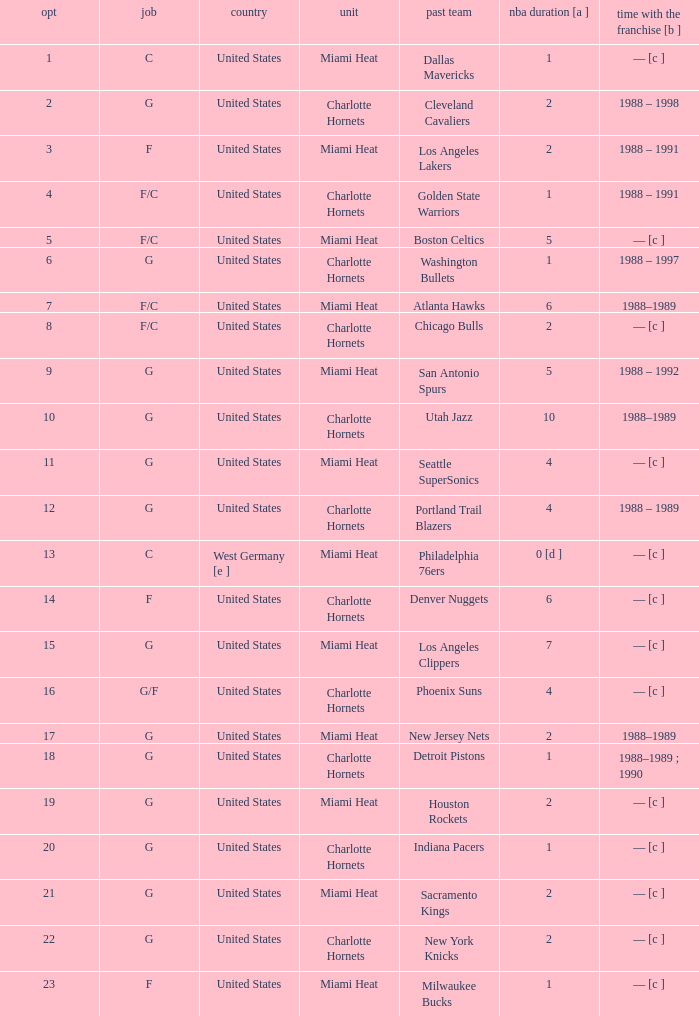How many NBA years did the player from the United States who was previously on the los angeles lakers have? 2.0. 